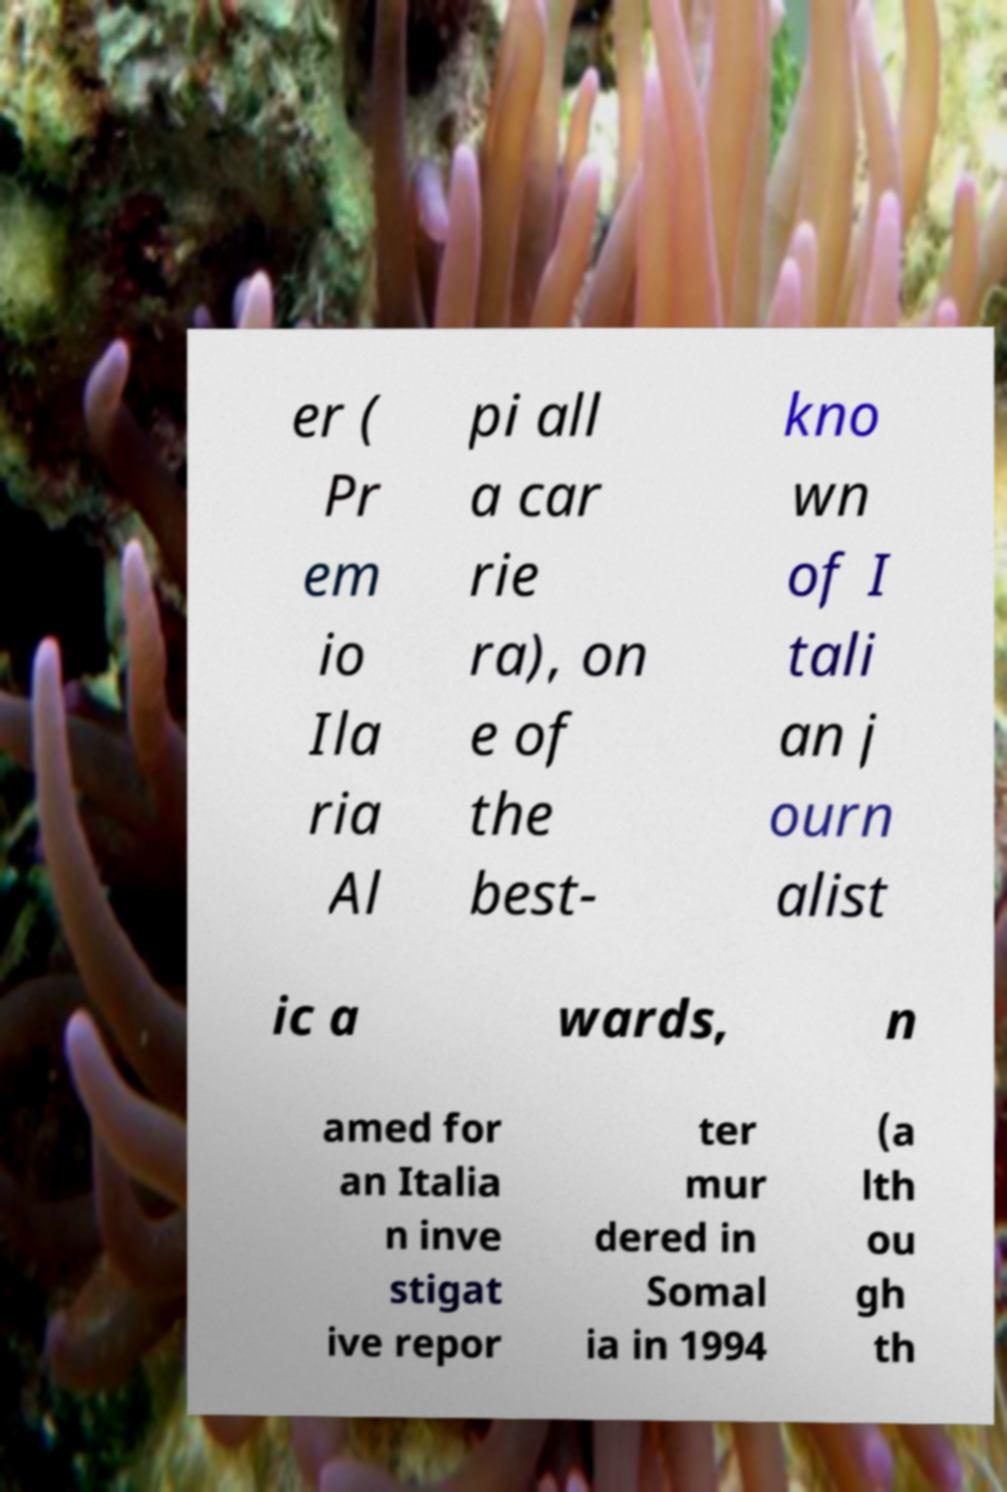Could you extract and type out the text from this image? er ( Pr em io Ila ria Al pi all a car rie ra), on e of the best- kno wn of I tali an j ourn alist ic a wards, n amed for an Italia n inve stigat ive repor ter mur dered in Somal ia in 1994 (a lth ou gh th 